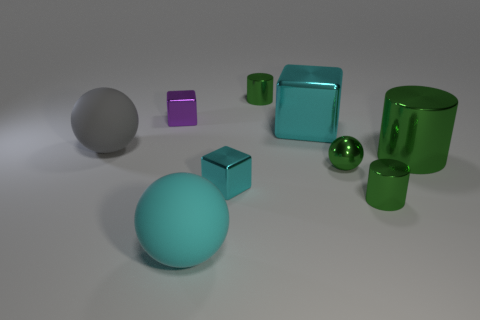Is the number of large metallic cylinders to the right of the large green object the same as the number of shiny cylinders?
Provide a short and direct response. No. Is there anything else that is the same size as the green metal ball?
Your answer should be very brief. Yes. The cyan object that is the same size as the purple metal block is what shape?
Provide a succinct answer. Cube. Is there a gray rubber object that has the same shape as the large cyan rubber object?
Offer a very short reply. Yes. Are there any tiny green shiny cylinders that are on the left side of the cube in front of the large matte ball behind the big green shiny object?
Your response must be concise. No. Are there more metal cubes that are behind the large cylinder than green cylinders behind the large cyan metallic cube?
Offer a very short reply. Yes. What material is the cylinder that is the same size as the gray ball?
Your answer should be very brief. Metal. How many small things are either cubes or cyan matte cylinders?
Make the answer very short. 2. Does the gray rubber object have the same shape as the cyan rubber thing?
Keep it short and to the point. Yes. How many things are right of the green metal ball and left of the big cylinder?
Give a very brief answer. 1. 